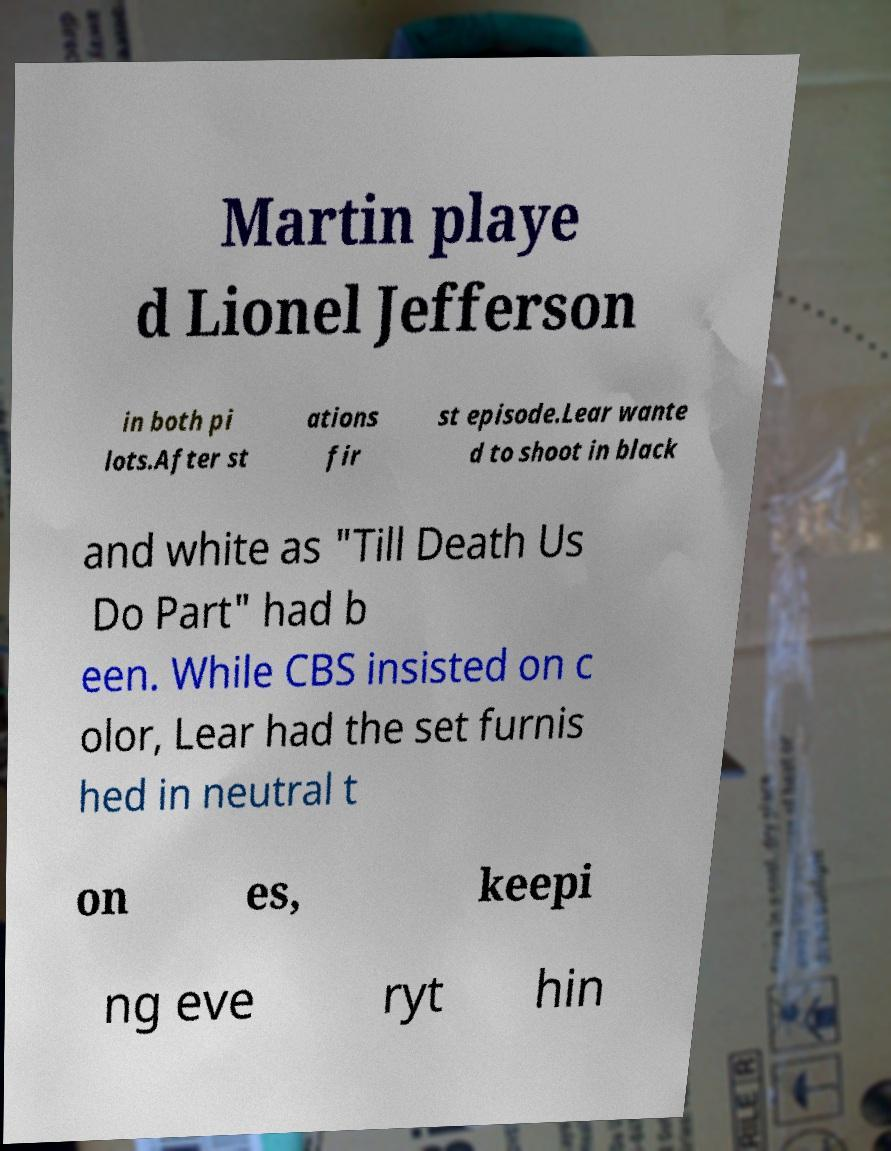I need the written content from this picture converted into text. Can you do that? Martin playe d Lionel Jefferson in both pi lots.After st ations fir st episode.Lear wante d to shoot in black and white as "Till Death Us Do Part" had b een. While CBS insisted on c olor, Lear had the set furnis hed in neutral t on es, keepi ng eve ryt hin 